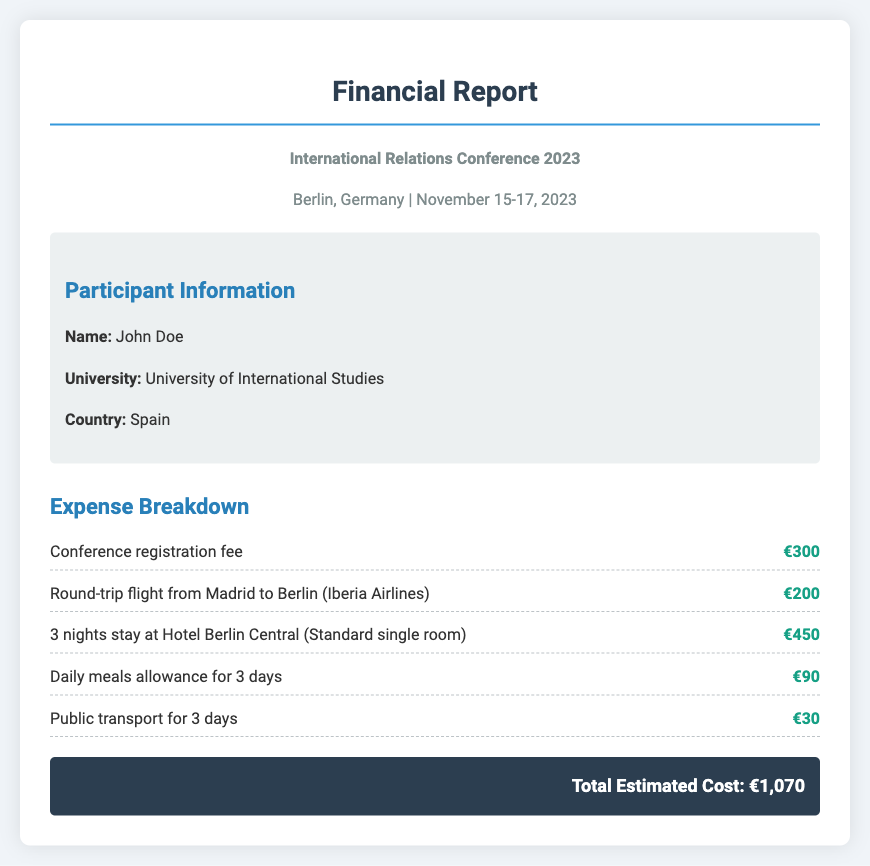What is the registration fee? The registration fee is explicitly stated in the expense breakdown section of the document.
Answer: €300 How much did the round-trip flight cost? The cost of the round-trip flight from Madrid to Berlin is detailed in the expense breakdown.
Answer: €200 What is the total estimated cost? The total estimated cost is summarized at the end of the expense breakdown.
Answer: €1,070 How many nights was the accommodation booked for? The number of nights for accommodation is specified in the expense breakdown.
Answer: 3 nights What is the name of the hotel where accommodation was booked? The hotel's name is mentioned in the expense breakdown related to accommodation.
Answer: Hotel Berlin Central What is the duration of the conference? The conference duration is provided in the event details at the beginning of the document.
Answer: November 15-17, 2023 How much was allocated for daily meals? The amount allocated for daily meals is found in the expense breakdown section.
Answer: €90 What city is the conference taking place in? The city for the conference is stated in the event details at the top of the document.
Answer: Berlin How many days of public transport expenses are listed? The document specifies the days for public transport expenses in the expense breakdown.
Answer: 3 days 